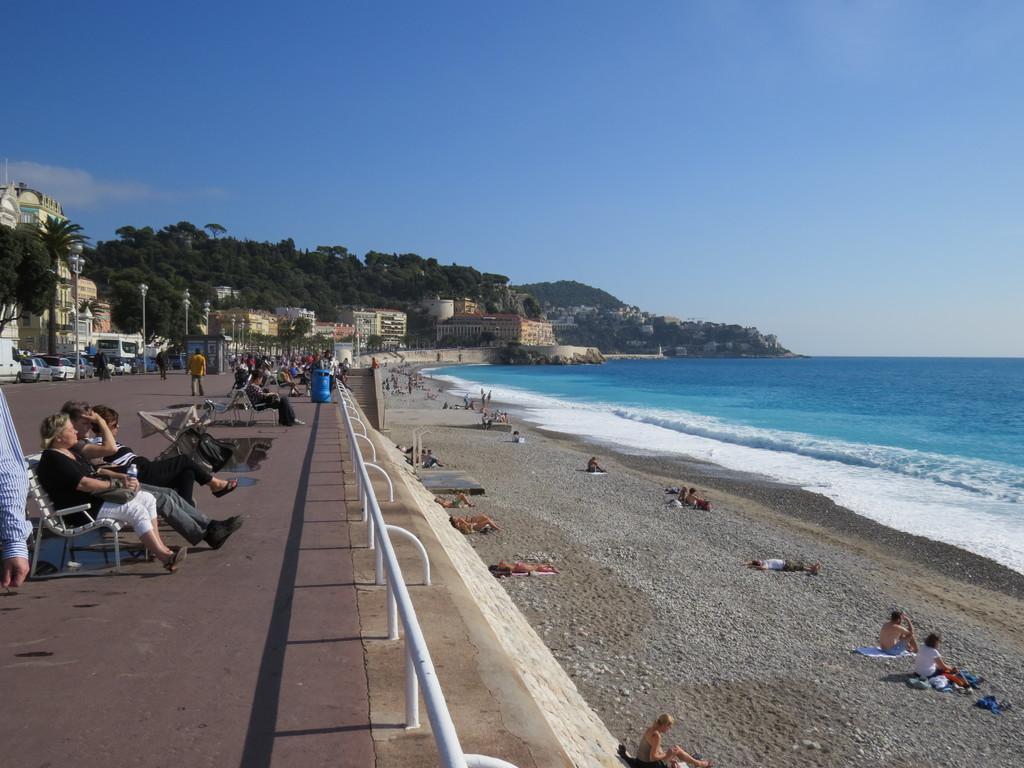How would you summarize this image in a sentence or two? In this image I can see few buildings, windows, trees, light poles, few people, few vehicles, stairs and few objects. I can see few people are sitting and few people are walking. I can see the water and the sky. 